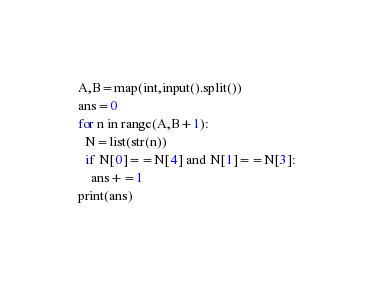<code> <loc_0><loc_0><loc_500><loc_500><_Python_>A,B=map(int,input().split())
ans=0
for n in range(A,B+1):
  N=list(str(n))
  if N[0]==N[4] and N[1]==N[3]:
    ans+=1
print(ans)</code> 